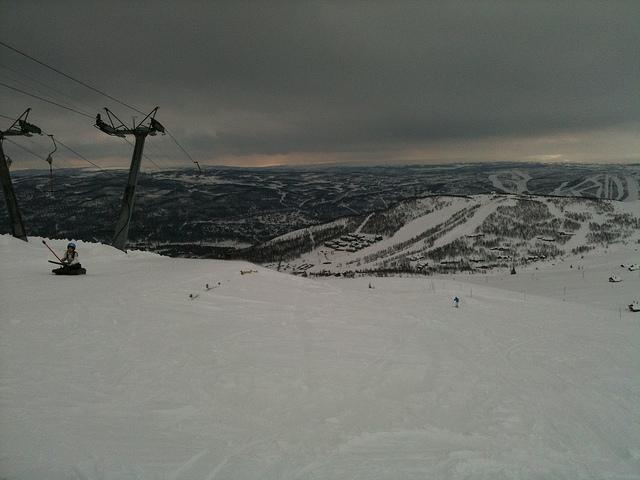What are the overhead cables for? Please explain your reasoning. carry skiers. The cables are for the ski lift which carries skiiers. 